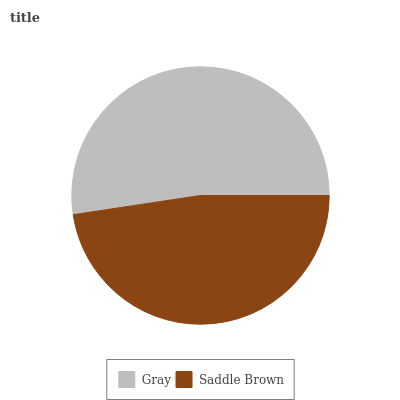Is Saddle Brown the minimum?
Answer yes or no. Yes. Is Gray the maximum?
Answer yes or no. Yes. Is Saddle Brown the maximum?
Answer yes or no. No. Is Gray greater than Saddle Brown?
Answer yes or no. Yes. Is Saddle Brown less than Gray?
Answer yes or no. Yes. Is Saddle Brown greater than Gray?
Answer yes or no. No. Is Gray less than Saddle Brown?
Answer yes or no. No. Is Gray the high median?
Answer yes or no. Yes. Is Saddle Brown the low median?
Answer yes or no. Yes. Is Saddle Brown the high median?
Answer yes or no. No. Is Gray the low median?
Answer yes or no. No. 